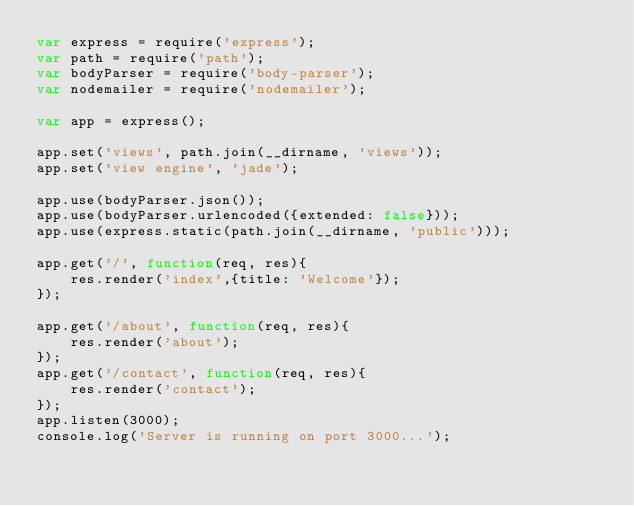<code> <loc_0><loc_0><loc_500><loc_500><_JavaScript_>var express = require('express');
var path = require('path');
var bodyParser = require('body-parser');
var nodemailer = require('nodemailer');

var app = express();

app.set('views', path.join(__dirname, 'views'));
app.set('view engine', 'jade');

app.use(bodyParser.json());
app.use(bodyParser.urlencoded({extended: false}));
app.use(express.static(path.join(__dirname, 'public')));

app.get('/', function(req, res){
	res.render('index',{title: 'Welcome'});
});

app.get('/about', function(req, res){
	res.render('about');
});
app.get('/contact', function(req, res){
	res.render('contact');
});
app.listen(3000);
console.log('Server is running on port 3000...');</code> 